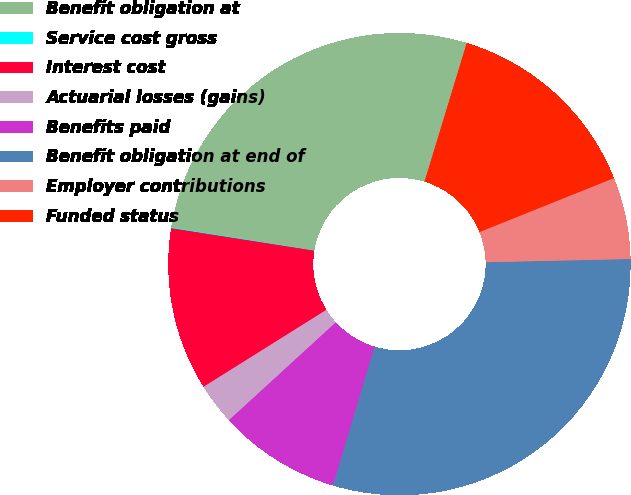Convert chart. <chart><loc_0><loc_0><loc_500><loc_500><pie_chart><fcel>Benefit obligation at<fcel>Service cost gross<fcel>Interest cost<fcel>Actuarial losses (gains)<fcel>Benefits paid<fcel>Benefit obligation at end of<fcel>Employer contributions<fcel>Funded status<nl><fcel>27.16%<fcel>0.06%<fcel>11.39%<fcel>2.89%<fcel>8.56%<fcel>29.99%<fcel>5.72%<fcel>14.22%<nl></chart> 